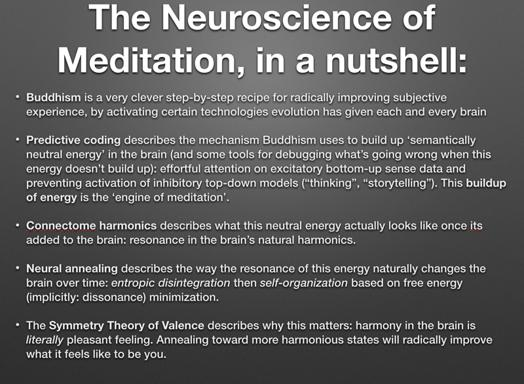How does meditation influence predictive coding according to the text? According to the text, meditation influences predictive coding by optimizing the buildup of neutral energy, which facilitates a more effective cognitive process to debug and manage sensory information, improving overall cognitive function. 